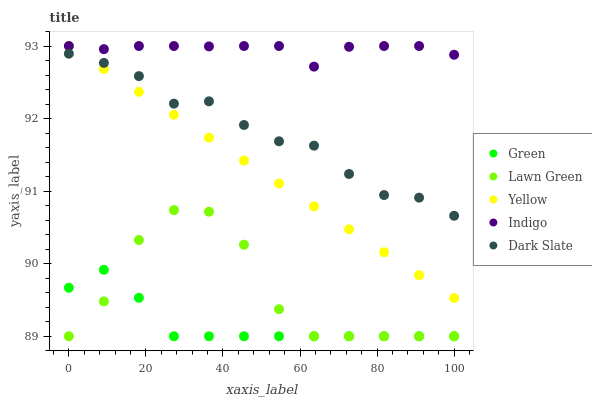Does Green have the minimum area under the curve?
Answer yes or no. Yes. Does Indigo have the maximum area under the curve?
Answer yes or no. Yes. Does Dark Slate have the minimum area under the curve?
Answer yes or no. No. Does Dark Slate have the maximum area under the curve?
Answer yes or no. No. Is Yellow the smoothest?
Answer yes or no. Yes. Is Lawn Green the roughest?
Answer yes or no. Yes. Is Green the smoothest?
Answer yes or no. No. Is Green the roughest?
Answer yes or no. No. Does Lawn Green have the lowest value?
Answer yes or no. Yes. Does Dark Slate have the lowest value?
Answer yes or no. No. Does Indigo have the highest value?
Answer yes or no. Yes. Does Dark Slate have the highest value?
Answer yes or no. No. Is Green less than Indigo?
Answer yes or no. Yes. Is Indigo greater than Dark Slate?
Answer yes or no. Yes. Does Green intersect Lawn Green?
Answer yes or no. Yes. Is Green less than Lawn Green?
Answer yes or no. No. Is Green greater than Lawn Green?
Answer yes or no. No. Does Green intersect Indigo?
Answer yes or no. No. 